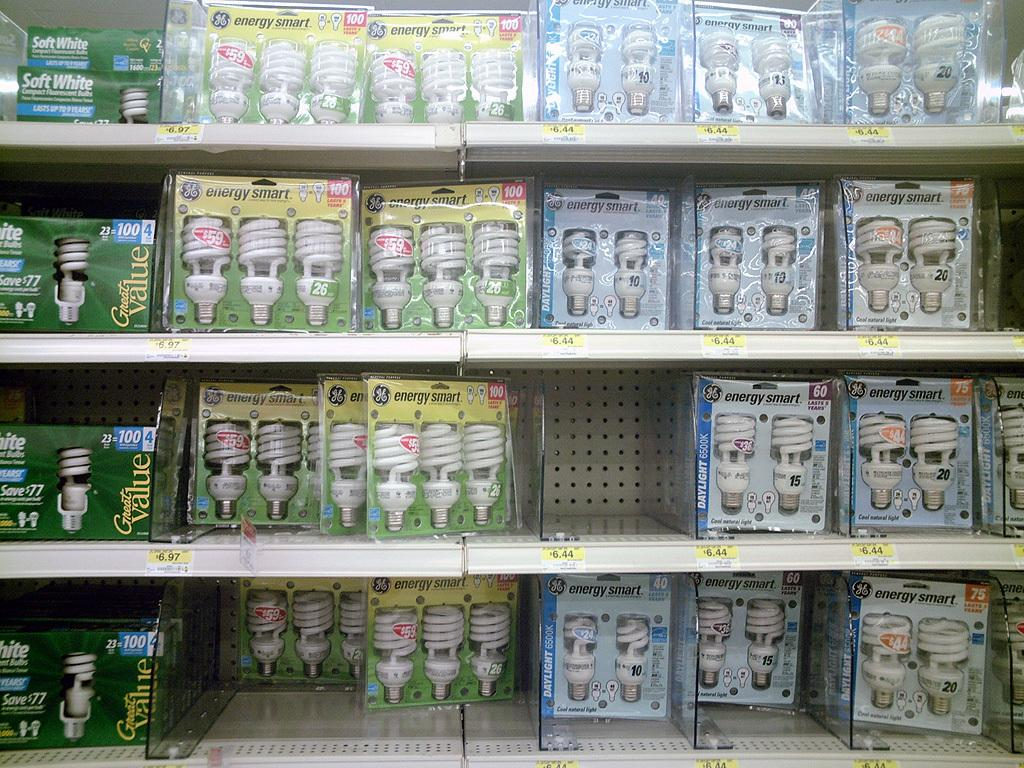What can be seen on the shelves in the image? There are light bulbs on the shelves in the image. How many shelves are visible in the image? The number of shelves is not specified, but at least one shelf is visible with light bulbs on it. How many bikes are parked on the shelves in the image? There are no bikes present on the shelves in the image; only light bulbs are visible. What type of patch is sewn onto the light bulbs in the image? There are no patches present on the light bulbs in the image; they are simply light bulbs. 